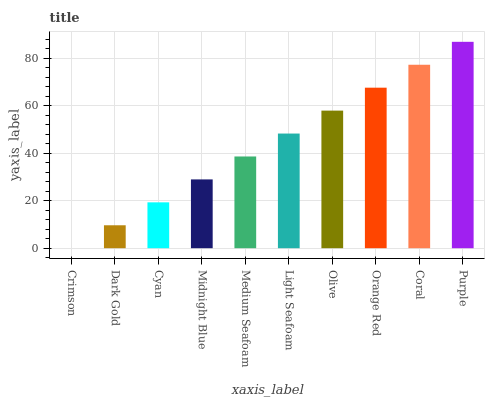Is Dark Gold the minimum?
Answer yes or no. No. Is Dark Gold the maximum?
Answer yes or no. No. Is Dark Gold greater than Crimson?
Answer yes or no. Yes. Is Crimson less than Dark Gold?
Answer yes or no. Yes. Is Crimson greater than Dark Gold?
Answer yes or no. No. Is Dark Gold less than Crimson?
Answer yes or no. No. Is Light Seafoam the high median?
Answer yes or no. Yes. Is Medium Seafoam the low median?
Answer yes or no. Yes. Is Purple the high median?
Answer yes or no. No. Is Olive the low median?
Answer yes or no. No. 